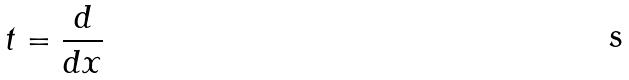<formula> <loc_0><loc_0><loc_500><loc_500>t = \frac { d } { d x }</formula> 